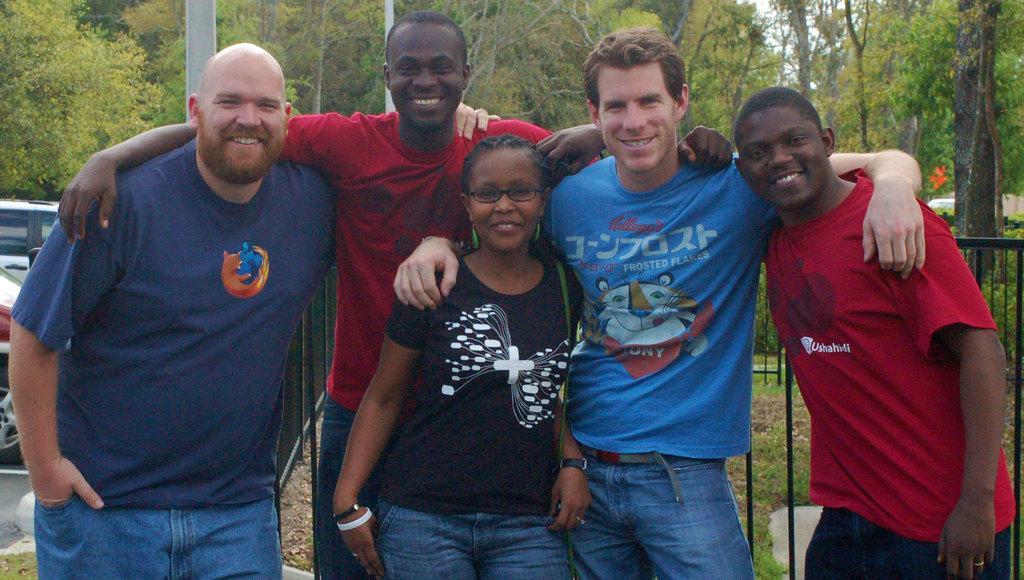Please provide a concise description of this image. In the foreground, I can see five persons are standing on grass. In the background, I can see a fence, vehicles on the road, trees, poles, grass and the sky. This image taken, maybe during a day. 